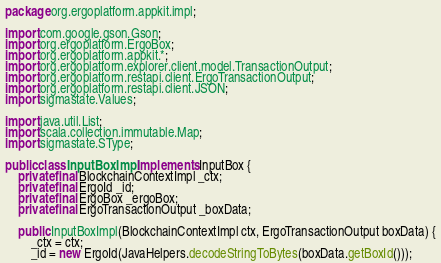<code> <loc_0><loc_0><loc_500><loc_500><_Java_>package org.ergoplatform.appkit.impl;

import com.google.gson.Gson;
import org.ergoplatform.ErgoBox;
import org.ergoplatform.appkit.*;
import org.ergoplatform.explorer.client.model.TransactionOutput;
import org.ergoplatform.restapi.client.ErgoTransactionOutput;
import org.ergoplatform.restapi.client.JSON;
import sigmastate.Values;

import java.util.List;
import scala.collection.immutable.Map;
import sigmastate.SType;

public class InputBoxImpl implements InputBox {
    private final BlockchainContextImpl _ctx;
    private final ErgoId _id;
    private final ErgoBox _ergoBox;
    private final ErgoTransactionOutput _boxData;

    public InputBoxImpl(BlockchainContextImpl ctx, ErgoTransactionOutput boxData) {
        _ctx = ctx;
        _id = new ErgoId(JavaHelpers.decodeStringToBytes(boxData.getBoxId()));</code> 